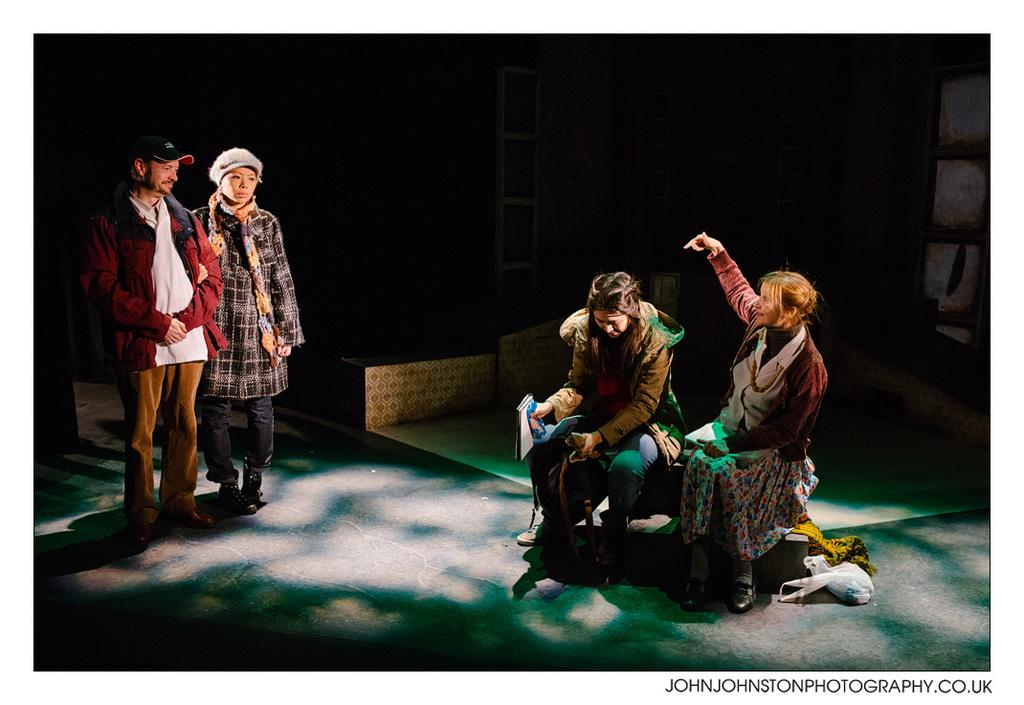How many people are sitting on the bench in the image? There are two women sitting on a bench in the image. What is happening in the background of the image? There is a man and a woman standing in the background. Can you describe the lighting in the image? The image appears to be dark. Is there any text visible in the image? Yes, there is text in the bottom right corner of the image. How many ducks are visible in the image? There are no ducks present in the image. What disease might the man in the background be suffering from? There is no information about the man's health in the image, so it is not possible to determine if he has any disease. 